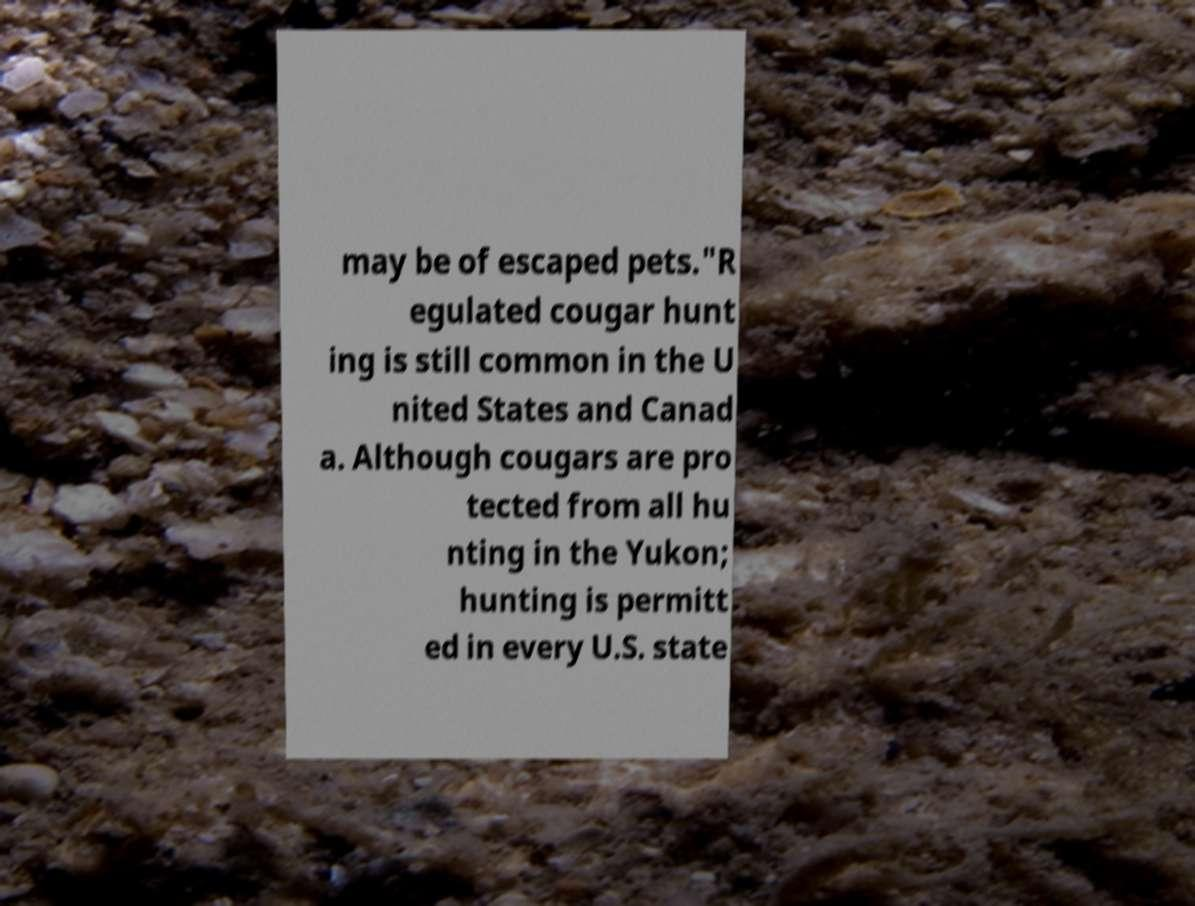For documentation purposes, I need the text within this image transcribed. Could you provide that? may be of escaped pets."R egulated cougar hunt ing is still common in the U nited States and Canad a. Although cougars are pro tected from all hu nting in the Yukon; hunting is permitt ed in every U.S. state 